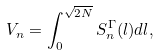<formula> <loc_0><loc_0><loc_500><loc_500>V _ { n } = \int _ { 0 } ^ { \sqrt { 2 N } } S ^ { \Gamma } _ { n } ( l ) d l ,</formula> 